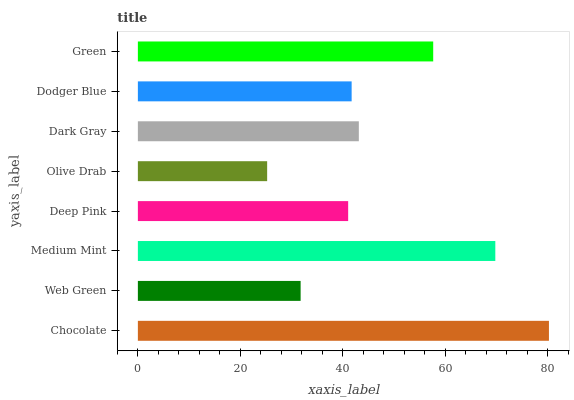Is Olive Drab the minimum?
Answer yes or no. Yes. Is Chocolate the maximum?
Answer yes or no. Yes. Is Web Green the minimum?
Answer yes or no. No. Is Web Green the maximum?
Answer yes or no. No. Is Chocolate greater than Web Green?
Answer yes or no. Yes. Is Web Green less than Chocolate?
Answer yes or no. Yes. Is Web Green greater than Chocolate?
Answer yes or no. No. Is Chocolate less than Web Green?
Answer yes or no. No. Is Dark Gray the high median?
Answer yes or no. Yes. Is Dodger Blue the low median?
Answer yes or no. Yes. Is Olive Drab the high median?
Answer yes or no. No. Is Green the low median?
Answer yes or no. No. 